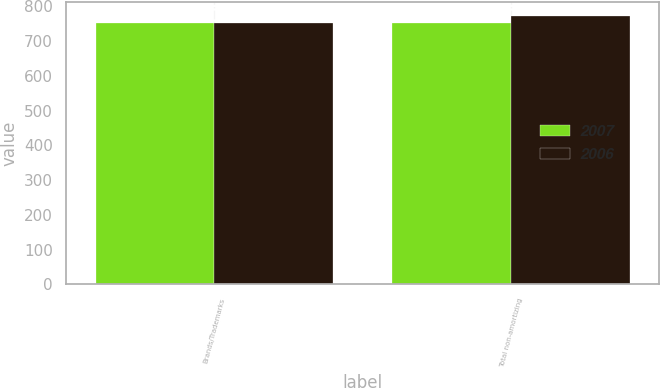Convert chart to OTSL. <chart><loc_0><loc_0><loc_500><loc_500><stacked_bar_chart><ecel><fcel>Brands/Trademarks<fcel>Total non-amortizing<nl><fcel>2007<fcel>752.6<fcel>752.6<nl><fcel>2006<fcel>752.6<fcel>773.1<nl></chart> 